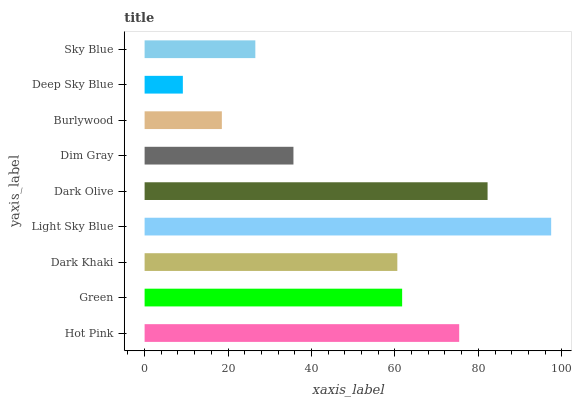Is Deep Sky Blue the minimum?
Answer yes or no. Yes. Is Light Sky Blue the maximum?
Answer yes or no. Yes. Is Green the minimum?
Answer yes or no. No. Is Green the maximum?
Answer yes or no. No. Is Hot Pink greater than Green?
Answer yes or no. Yes. Is Green less than Hot Pink?
Answer yes or no. Yes. Is Green greater than Hot Pink?
Answer yes or no. No. Is Hot Pink less than Green?
Answer yes or no. No. Is Dark Khaki the high median?
Answer yes or no. Yes. Is Dark Khaki the low median?
Answer yes or no. Yes. Is Deep Sky Blue the high median?
Answer yes or no. No. Is Deep Sky Blue the low median?
Answer yes or no. No. 